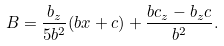<formula> <loc_0><loc_0><loc_500><loc_500>B = \frac { b _ { z } } { 5 b ^ { 2 } } ( b x + c ) + \frac { b c _ { z } - b _ { z } c } { b ^ { 2 } } .</formula> 